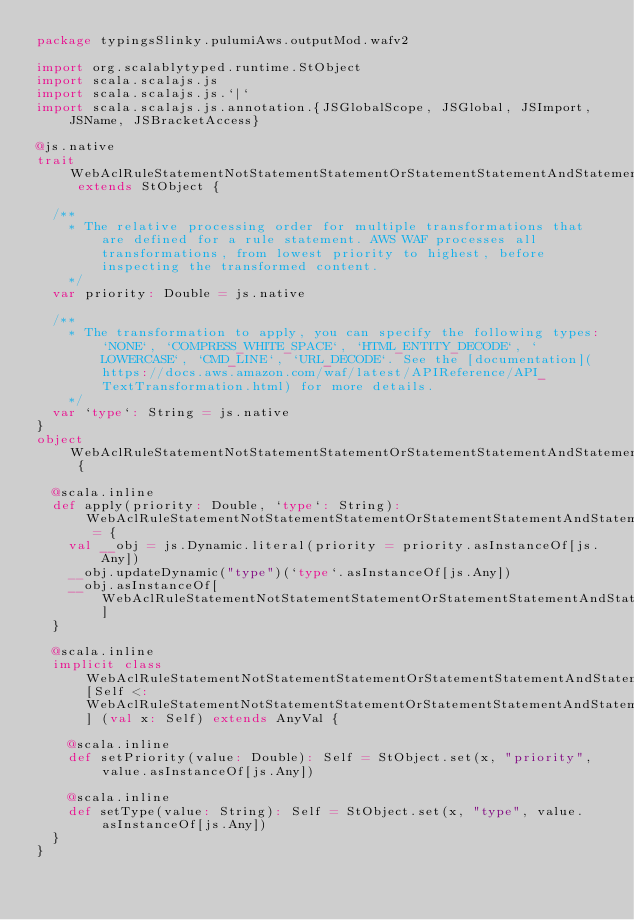Convert code to text. <code><loc_0><loc_0><loc_500><loc_500><_Scala_>package typingsSlinky.pulumiAws.outputMod.wafv2

import org.scalablytyped.runtime.StObject
import scala.scalajs.js
import scala.scalajs.js.`|`
import scala.scalajs.js.annotation.{JSGlobalScope, JSGlobal, JSImport, JSName, JSBracketAccess}

@js.native
trait WebAclRuleStatementNotStatementStatementOrStatementStatementAndStatementStatementXssMatchStatementTextTransformation extends StObject {
  
  /**
    * The relative processing order for multiple transformations that are defined for a rule statement. AWS WAF processes all transformations, from lowest priority to highest, before inspecting the transformed content.
    */
  var priority: Double = js.native
  
  /**
    * The transformation to apply, you can specify the following types: `NONE`, `COMPRESS_WHITE_SPACE`, `HTML_ENTITY_DECODE`, `LOWERCASE`, `CMD_LINE`, `URL_DECODE`. See the [documentation](https://docs.aws.amazon.com/waf/latest/APIReference/API_TextTransformation.html) for more details.
    */
  var `type`: String = js.native
}
object WebAclRuleStatementNotStatementStatementOrStatementStatementAndStatementStatementXssMatchStatementTextTransformation {
  
  @scala.inline
  def apply(priority: Double, `type`: String): WebAclRuleStatementNotStatementStatementOrStatementStatementAndStatementStatementXssMatchStatementTextTransformation = {
    val __obj = js.Dynamic.literal(priority = priority.asInstanceOf[js.Any])
    __obj.updateDynamic("type")(`type`.asInstanceOf[js.Any])
    __obj.asInstanceOf[WebAclRuleStatementNotStatementStatementOrStatementStatementAndStatementStatementXssMatchStatementTextTransformation]
  }
  
  @scala.inline
  implicit class WebAclRuleStatementNotStatementStatementOrStatementStatementAndStatementStatementXssMatchStatementTextTransformationMutableBuilder[Self <: WebAclRuleStatementNotStatementStatementOrStatementStatementAndStatementStatementXssMatchStatementTextTransformation] (val x: Self) extends AnyVal {
    
    @scala.inline
    def setPriority(value: Double): Self = StObject.set(x, "priority", value.asInstanceOf[js.Any])
    
    @scala.inline
    def setType(value: String): Self = StObject.set(x, "type", value.asInstanceOf[js.Any])
  }
}
</code> 